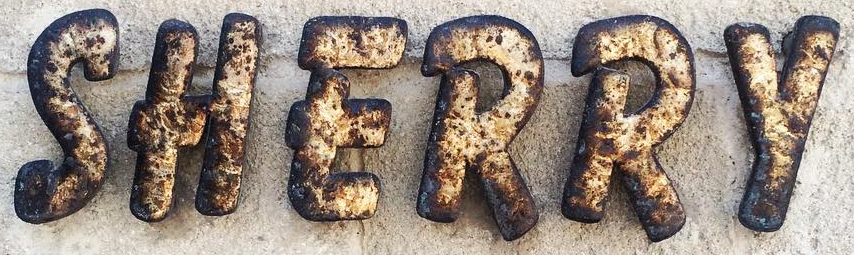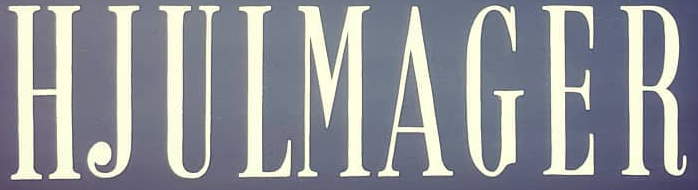What text appears in these images from left to right, separated by a semicolon? SHERRY; HJULMAGER 